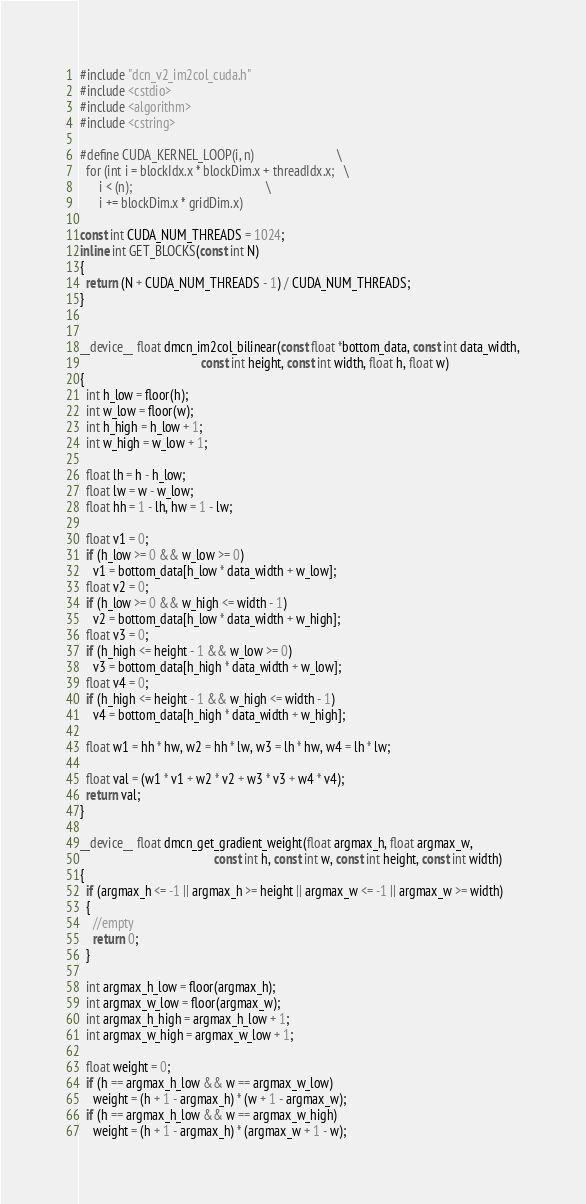Convert code to text. <code><loc_0><loc_0><loc_500><loc_500><_Cuda_>#include "dcn_v2_im2col_cuda.h"
#include <cstdio>
#include <algorithm>
#include <cstring>

#define CUDA_KERNEL_LOOP(i, n)                          \
  for (int i = blockIdx.x * blockDim.x + threadIdx.x;   \
      i < (n);                                          \
      i += blockDim.x * gridDim.x)

const int CUDA_NUM_THREADS = 1024;
inline int GET_BLOCKS(const int N)
{
  return (N + CUDA_NUM_THREADS - 1) / CUDA_NUM_THREADS;
}


__device__ float dmcn_im2col_bilinear(const float *bottom_data, const int data_width,
                                      const int height, const int width, float h, float w)
{
  int h_low = floor(h);
  int w_low = floor(w);
  int h_high = h_low + 1;
  int w_high = w_low + 1;

  float lh = h - h_low;
  float lw = w - w_low;
  float hh = 1 - lh, hw = 1 - lw;

  float v1 = 0;
  if (h_low >= 0 && w_low >= 0)
    v1 = bottom_data[h_low * data_width + w_low];
  float v2 = 0;
  if (h_low >= 0 && w_high <= width - 1)
    v2 = bottom_data[h_low * data_width + w_high];
  float v3 = 0;
  if (h_high <= height - 1 && w_low >= 0)
    v3 = bottom_data[h_high * data_width + w_low];
  float v4 = 0;
  if (h_high <= height - 1 && w_high <= width - 1)
    v4 = bottom_data[h_high * data_width + w_high];

  float w1 = hh * hw, w2 = hh * lw, w3 = lh * hw, w4 = lh * lw;

  float val = (w1 * v1 + w2 * v2 + w3 * v3 + w4 * v4);
  return val;
}

__device__ float dmcn_get_gradient_weight(float argmax_h, float argmax_w,
                                          const int h, const int w, const int height, const int width)
{
  if (argmax_h <= -1 || argmax_h >= height || argmax_w <= -1 || argmax_w >= width)
  {
    //empty
    return 0;
  }

  int argmax_h_low = floor(argmax_h);
  int argmax_w_low = floor(argmax_w);
  int argmax_h_high = argmax_h_low + 1;
  int argmax_w_high = argmax_w_low + 1;

  float weight = 0;
  if (h == argmax_h_low && w == argmax_w_low)
    weight = (h + 1 - argmax_h) * (w + 1 - argmax_w);
  if (h == argmax_h_low && w == argmax_w_high)
    weight = (h + 1 - argmax_h) * (argmax_w + 1 - w);</code> 